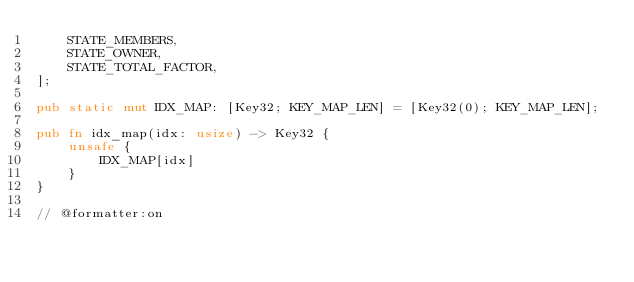<code> <loc_0><loc_0><loc_500><loc_500><_Rust_>    STATE_MEMBERS,
    STATE_OWNER,
    STATE_TOTAL_FACTOR,
];

pub static mut IDX_MAP: [Key32; KEY_MAP_LEN] = [Key32(0); KEY_MAP_LEN];

pub fn idx_map(idx: usize) -> Key32 {
    unsafe {
        IDX_MAP[idx]
    }
}

// @formatter:on
</code> 